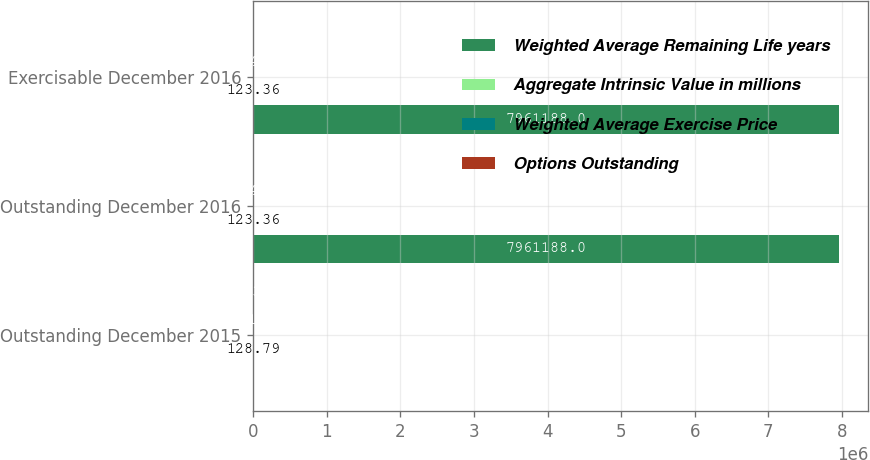Convert chart. <chart><loc_0><loc_0><loc_500><loc_500><stacked_bar_chart><ecel><fcel>Outstanding December 2015<fcel>Outstanding December 2016<fcel>Exercisable December 2016<nl><fcel>Weighted Average Remaining Life years<fcel>128.79<fcel>7.96119e+06<fcel>7.96119e+06<nl><fcel>Aggregate Intrinsic Value in millions<fcel>128.79<fcel>123.36<fcel>123.36<nl><fcel>Weighted Average Exercise Price<fcel>891<fcel>924<fcel>924<nl><fcel>Options Outstanding<fcel>2.38<fcel>1.61<fcel>1.61<nl></chart> 